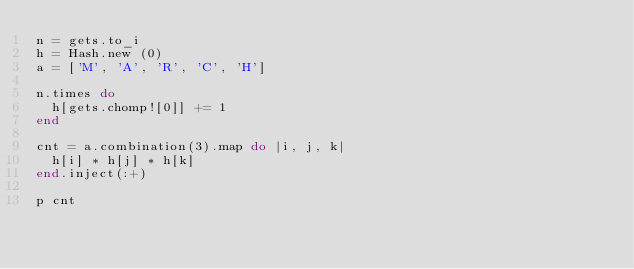Convert code to text. <code><loc_0><loc_0><loc_500><loc_500><_Ruby_>n = gets.to_i
h = Hash.new (0)
a = ['M', 'A', 'R', 'C', 'H']

n.times do
  h[gets.chomp![0]] += 1
end

cnt = a.combination(3).map do |i, j, k|
  h[i] * h[j] * h[k]
end.inject(:+)

p cnt
</code> 